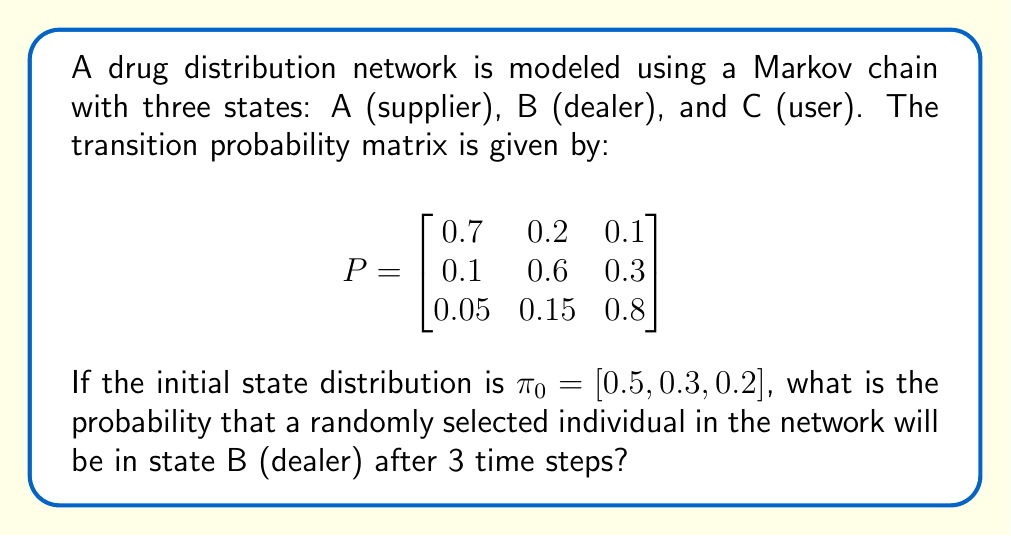What is the answer to this math problem? To solve this problem, we need to use the Chapman-Kolmogorov equations for Markov chains. The steps are as follows:

1) The probability distribution after n steps is given by:
   $\pi_n = \pi_0 P^n$

2) In this case, we need to calculate $P^3$. We can do this by multiplying P by itself three times:
   $P^3 = P \cdot P \cdot P$

3) Using a calculator or computer, we get:
   $$P^3 = \begin{bmatrix}
   0.5185 & 0.2630 & 0.2185 \\
   0.2135 & 0.4405 & 0.3460 \\
   0.1470 & 0.2655 & 0.5875
   \end{bmatrix}$$

4) Now, we multiply the initial distribution $\pi_0$ by $P^3$:
   $\pi_3 = [0.5, 0.3, 0.2] \cdot P^3$

5) Performing this matrix multiplication:
   $\pi_3 = [0.3559, 0.3197, 0.3244]$

6) The probability of being in state B (dealer) after 3 time steps is the second element of $\pi_3$, which is 0.3197 or approximately 0.32.

This result suggests that after 3 time steps, there's about a 32% chance that a randomly selected individual in the network will be a dealer.
Answer: 0.3197 